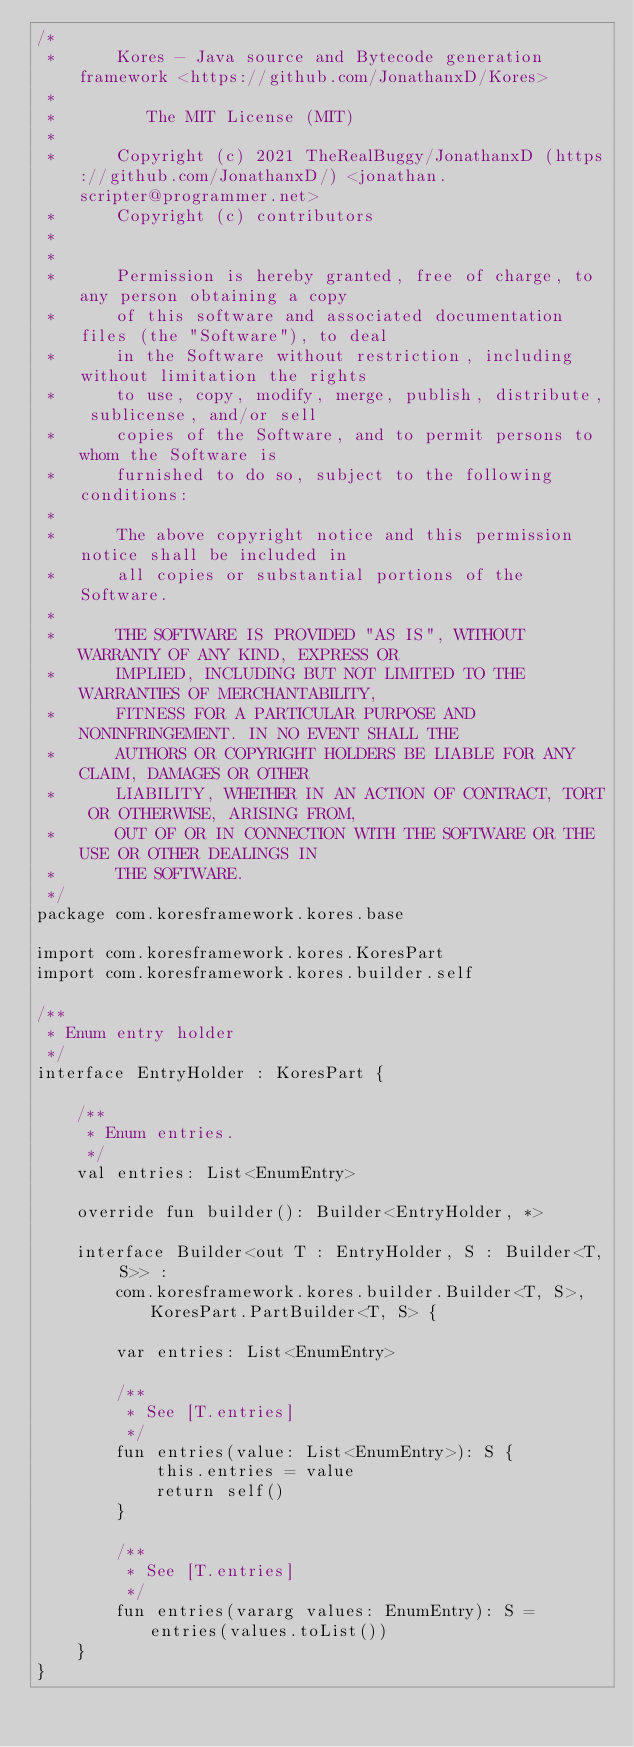<code> <loc_0><loc_0><loc_500><loc_500><_Kotlin_>/*
 *      Kores - Java source and Bytecode generation framework <https://github.com/JonathanxD/Kores>
 *
 *         The MIT License (MIT)
 *
 *      Copyright (c) 2021 TheRealBuggy/JonathanxD (https://github.com/JonathanxD/) <jonathan.scripter@programmer.net>
 *      Copyright (c) contributors
 *
 *
 *      Permission is hereby granted, free of charge, to any person obtaining a copy
 *      of this software and associated documentation files (the "Software"), to deal
 *      in the Software without restriction, including without limitation the rights
 *      to use, copy, modify, merge, publish, distribute, sublicense, and/or sell
 *      copies of the Software, and to permit persons to whom the Software is
 *      furnished to do so, subject to the following conditions:
 *
 *      The above copyright notice and this permission notice shall be included in
 *      all copies or substantial portions of the Software.
 *
 *      THE SOFTWARE IS PROVIDED "AS IS", WITHOUT WARRANTY OF ANY KIND, EXPRESS OR
 *      IMPLIED, INCLUDING BUT NOT LIMITED TO THE WARRANTIES OF MERCHANTABILITY,
 *      FITNESS FOR A PARTICULAR PURPOSE AND NONINFRINGEMENT. IN NO EVENT SHALL THE
 *      AUTHORS OR COPYRIGHT HOLDERS BE LIABLE FOR ANY CLAIM, DAMAGES OR OTHER
 *      LIABILITY, WHETHER IN AN ACTION OF CONTRACT, TORT OR OTHERWISE, ARISING FROM,
 *      OUT OF OR IN CONNECTION WITH THE SOFTWARE OR THE USE OR OTHER DEALINGS IN
 *      THE SOFTWARE.
 */
package com.koresframework.kores.base

import com.koresframework.kores.KoresPart
import com.koresframework.kores.builder.self

/**
 * Enum entry holder
 */
interface EntryHolder : KoresPart {

    /**
     * Enum entries.
     */
    val entries: List<EnumEntry>

    override fun builder(): Builder<EntryHolder, *>

    interface Builder<out T : EntryHolder, S : Builder<T, S>> :
        com.koresframework.kores.builder.Builder<T, S>, KoresPart.PartBuilder<T, S> {

        var entries: List<EnumEntry>

        /**
         * See [T.entries]
         */
        fun entries(value: List<EnumEntry>): S {
            this.entries = value
            return self()
        }

        /**
         * See [T.entries]
         */
        fun entries(vararg values: EnumEntry): S = entries(values.toList())
    }
}</code> 